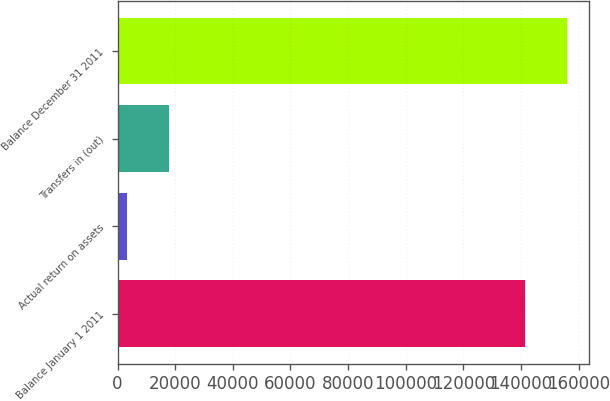Convert chart. <chart><loc_0><loc_0><loc_500><loc_500><bar_chart><fcel>Balance January 1 2011<fcel>Actual return on assets<fcel>Transfers in (out)<fcel>Balance December 31 2011<nl><fcel>141403<fcel>3425<fcel>17939.9<fcel>155918<nl></chart> 